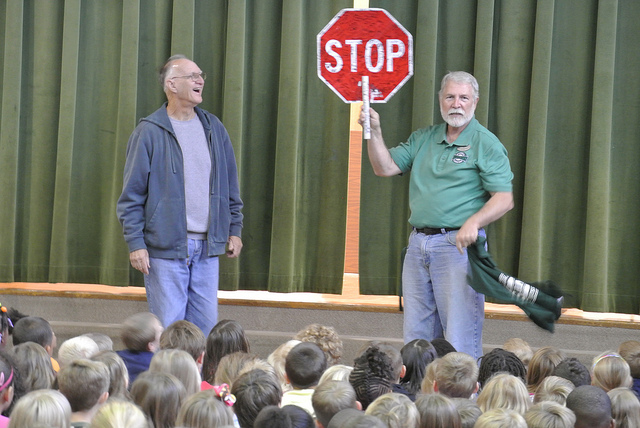Please transcribe the text information in this image. STOP 